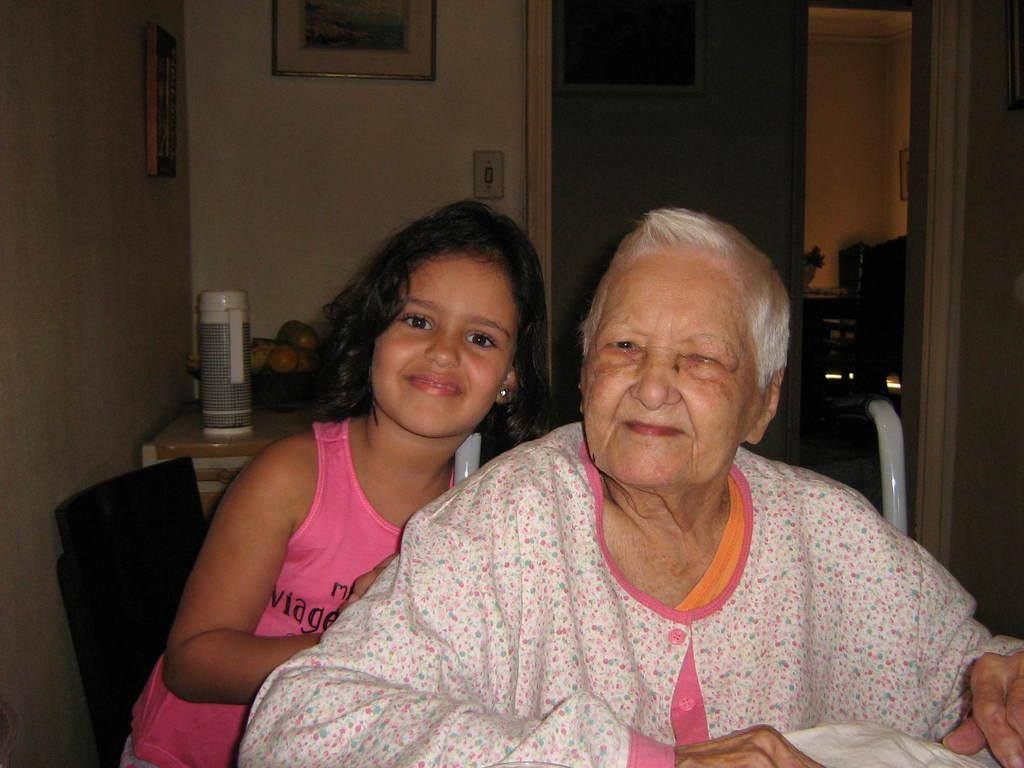Who are the people in the image? There is an old lady and a girl in the image. What can be seen in the background of the image? There is a wall with photo frames in the background. What furniture is present in the image? There is a table in the image. What items are on the table? There is a flask and a bowl with fruits on the table. What type of receipt can be seen on the table in the image? There is no receipt present on the table in the image. How many eggs are visible in the bowl with fruits on the table? There are no eggs in the bowl with fruits on the table; it contains only fruits. 